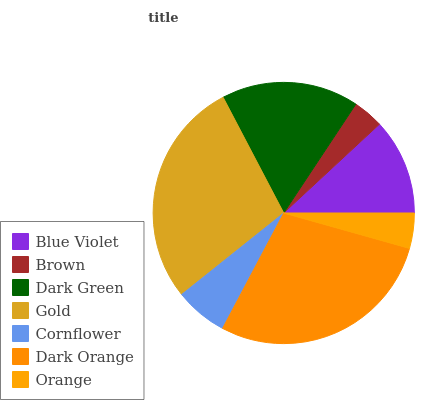Is Brown the minimum?
Answer yes or no. Yes. Is Dark Orange the maximum?
Answer yes or no. Yes. Is Dark Green the minimum?
Answer yes or no. No. Is Dark Green the maximum?
Answer yes or no. No. Is Dark Green greater than Brown?
Answer yes or no. Yes. Is Brown less than Dark Green?
Answer yes or no. Yes. Is Brown greater than Dark Green?
Answer yes or no. No. Is Dark Green less than Brown?
Answer yes or no. No. Is Blue Violet the high median?
Answer yes or no. Yes. Is Blue Violet the low median?
Answer yes or no. Yes. Is Dark Orange the high median?
Answer yes or no. No. Is Gold the low median?
Answer yes or no. No. 